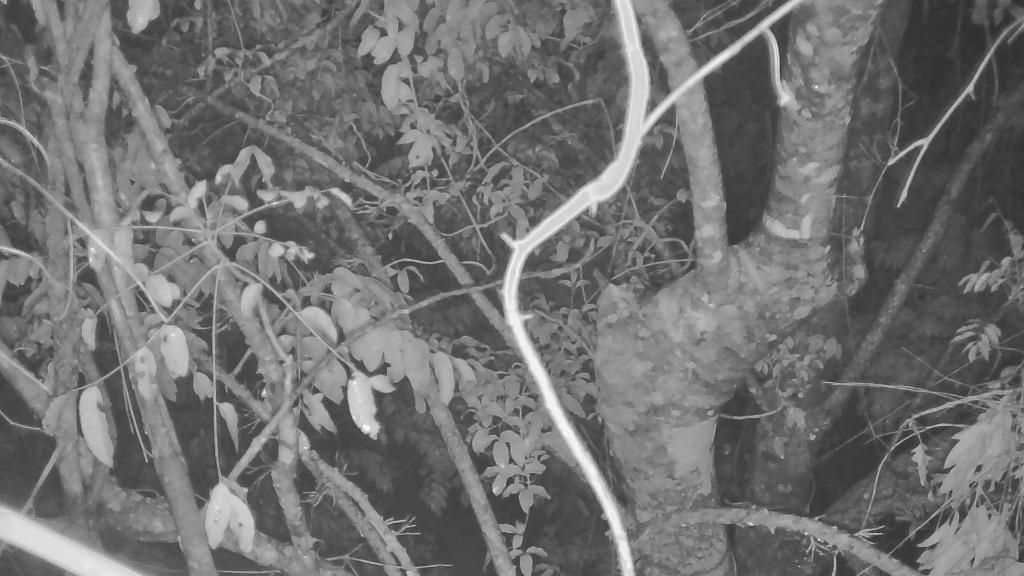What type of plant can be seen in the image? There is a tree in the image. What part of the tree is visible? The trunk of the tree is visible. What covers the branches of the tree? Leaves are present on the tree. What type of tax is being discussed in the image? There is no discussion of tax in the image; it features a tree with leaves and a visible trunk. 